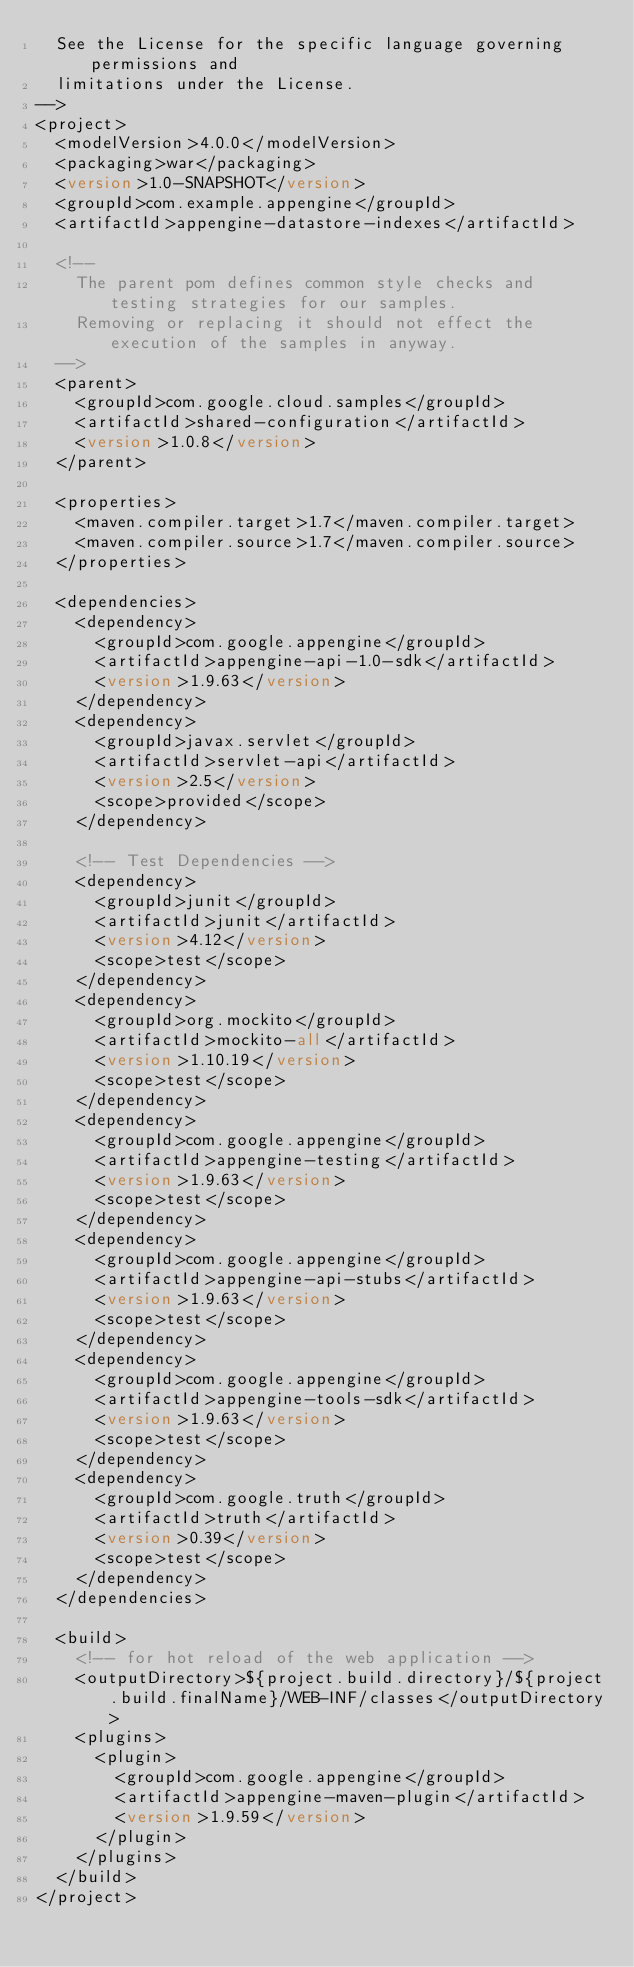Convert code to text. <code><loc_0><loc_0><loc_500><loc_500><_XML_>  See the License for the specific language governing permissions and
  limitations under the License.
-->
<project>
  <modelVersion>4.0.0</modelVersion>
  <packaging>war</packaging>
  <version>1.0-SNAPSHOT</version>
  <groupId>com.example.appengine</groupId>
  <artifactId>appengine-datastore-indexes</artifactId>

  <!--
    The parent pom defines common style checks and testing strategies for our samples.
    Removing or replacing it should not effect the execution of the samples in anyway.
  -->
  <parent>
    <groupId>com.google.cloud.samples</groupId>
    <artifactId>shared-configuration</artifactId>
    <version>1.0.8</version>
  </parent>

  <properties>
    <maven.compiler.target>1.7</maven.compiler.target>
    <maven.compiler.source>1.7</maven.compiler.source>
  </properties>

  <dependencies>
    <dependency>
      <groupId>com.google.appengine</groupId>
      <artifactId>appengine-api-1.0-sdk</artifactId>
      <version>1.9.63</version>
    </dependency>
    <dependency>
      <groupId>javax.servlet</groupId>
      <artifactId>servlet-api</artifactId>
      <version>2.5</version>
      <scope>provided</scope>
    </dependency>

    <!-- Test Dependencies -->
    <dependency>
      <groupId>junit</groupId>
      <artifactId>junit</artifactId>
      <version>4.12</version>
      <scope>test</scope>
    </dependency>
    <dependency>
      <groupId>org.mockito</groupId>
      <artifactId>mockito-all</artifactId>
      <version>1.10.19</version>
      <scope>test</scope>
    </dependency>
    <dependency>
      <groupId>com.google.appengine</groupId>
      <artifactId>appengine-testing</artifactId>
      <version>1.9.63</version>
      <scope>test</scope>
    </dependency>
    <dependency>
      <groupId>com.google.appengine</groupId>
      <artifactId>appengine-api-stubs</artifactId>
      <version>1.9.63</version>
      <scope>test</scope>
    </dependency>
    <dependency>
      <groupId>com.google.appengine</groupId>
      <artifactId>appengine-tools-sdk</artifactId>
      <version>1.9.63</version>
      <scope>test</scope>
    </dependency>
    <dependency>
      <groupId>com.google.truth</groupId>
      <artifactId>truth</artifactId>
      <version>0.39</version>
      <scope>test</scope>
    </dependency>
  </dependencies>

  <build>
    <!-- for hot reload of the web application -->
    <outputDirectory>${project.build.directory}/${project.build.finalName}/WEB-INF/classes</outputDirectory>
    <plugins>
      <plugin>
        <groupId>com.google.appengine</groupId>
        <artifactId>appengine-maven-plugin</artifactId>
        <version>1.9.59</version>
      </plugin>
    </plugins>
  </build>
</project>
</code> 